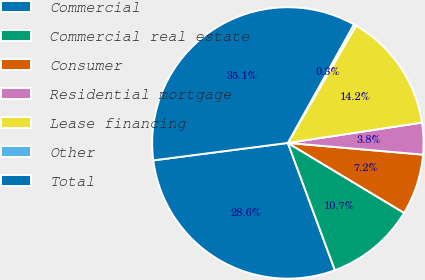Convert chart to OTSL. <chart><loc_0><loc_0><loc_500><loc_500><pie_chart><fcel>Commercial<fcel>Commercial real estate<fcel>Consumer<fcel>Residential mortgage<fcel>Lease financing<fcel>Other<fcel>Total<nl><fcel>28.59%<fcel>10.74%<fcel>7.25%<fcel>3.77%<fcel>14.23%<fcel>0.28%<fcel>35.15%<nl></chart> 